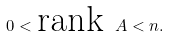<formula> <loc_0><loc_0><loc_500><loc_500>0 < \text {rank } A < n .</formula> 